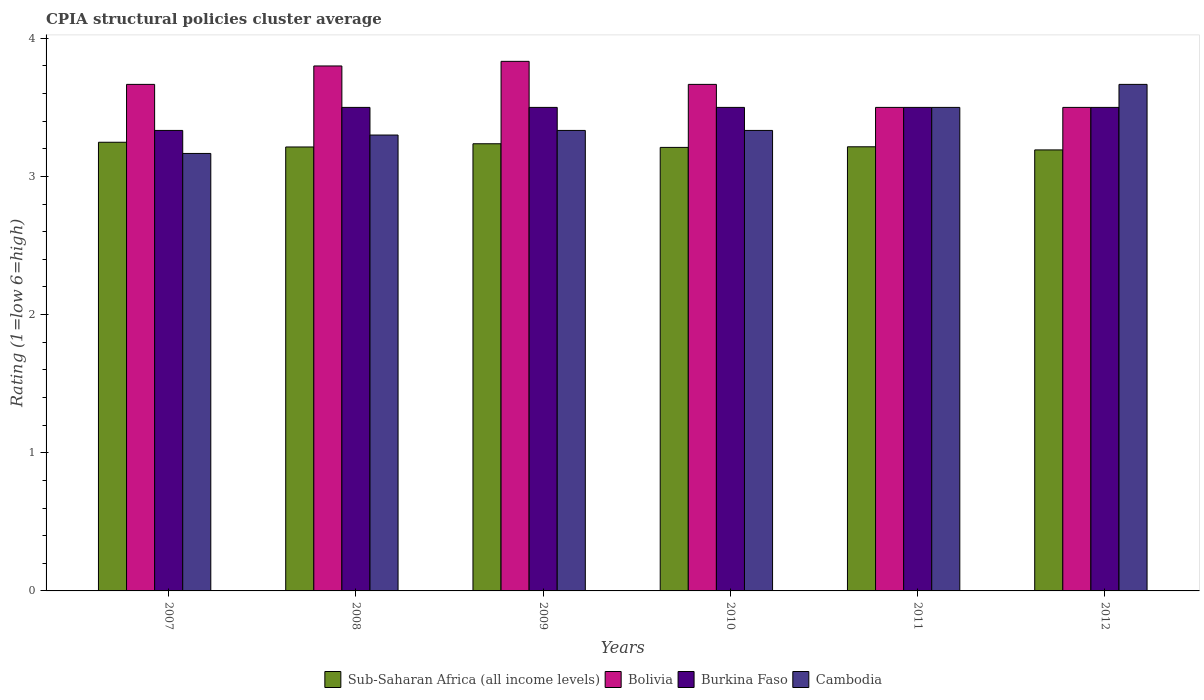How many groups of bars are there?
Provide a short and direct response. 6. Are the number of bars per tick equal to the number of legend labels?
Offer a very short reply. Yes. Are the number of bars on each tick of the X-axis equal?
Provide a succinct answer. Yes. What is the label of the 4th group of bars from the left?
Your response must be concise. 2010. What is the CPIA rating in Cambodia in 2010?
Offer a very short reply. 3.33. Across all years, what is the maximum CPIA rating in Bolivia?
Your answer should be compact. 3.83. Across all years, what is the minimum CPIA rating in Burkina Faso?
Your response must be concise. 3.33. In which year was the CPIA rating in Cambodia maximum?
Make the answer very short. 2012. In which year was the CPIA rating in Cambodia minimum?
Your response must be concise. 2007. What is the total CPIA rating in Bolivia in the graph?
Ensure brevity in your answer.  21.97. What is the difference between the CPIA rating in Sub-Saharan Africa (all income levels) in 2011 and that in 2012?
Provide a short and direct response. 0.02. What is the difference between the CPIA rating in Bolivia in 2010 and the CPIA rating in Sub-Saharan Africa (all income levels) in 2009?
Make the answer very short. 0.43. What is the average CPIA rating in Bolivia per year?
Your response must be concise. 3.66. In the year 2010, what is the difference between the CPIA rating in Bolivia and CPIA rating in Sub-Saharan Africa (all income levels)?
Your response must be concise. 0.46. In how many years, is the CPIA rating in Bolivia greater than 1.4?
Provide a short and direct response. 6. What is the ratio of the CPIA rating in Sub-Saharan Africa (all income levels) in 2011 to that in 2012?
Keep it short and to the point. 1.01. Is the CPIA rating in Sub-Saharan Africa (all income levels) in 2011 less than that in 2012?
Keep it short and to the point. No. Is the difference between the CPIA rating in Bolivia in 2008 and 2009 greater than the difference between the CPIA rating in Sub-Saharan Africa (all income levels) in 2008 and 2009?
Ensure brevity in your answer.  No. What is the difference between the highest and the second highest CPIA rating in Sub-Saharan Africa (all income levels)?
Your answer should be compact. 0.01. What is the difference between the highest and the lowest CPIA rating in Bolivia?
Ensure brevity in your answer.  0.33. In how many years, is the CPIA rating in Sub-Saharan Africa (all income levels) greater than the average CPIA rating in Sub-Saharan Africa (all income levels) taken over all years?
Your response must be concise. 2. How many bars are there?
Offer a very short reply. 24. How many years are there in the graph?
Your answer should be very brief. 6. Are the values on the major ticks of Y-axis written in scientific E-notation?
Make the answer very short. No. Does the graph contain grids?
Provide a succinct answer. No. How many legend labels are there?
Ensure brevity in your answer.  4. What is the title of the graph?
Your answer should be very brief. CPIA structural policies cluster average. What is the label or title of the X-axis?
Make the answer very short. Years. What is the Rating (1=low 6=high) in Sub-Saharan Africa (all income levels) in 2007?
Keep it short and to the point. 3.25. What is the Rating (1=low 6=high) of Bolivia in 2007?
Ensure brevity in your answer.  3.67. What is the Rating (1=low 6=high) of Burkina Faso in 2007?
Provide a succinct answer. 3.33. What is the Rating (1=low 6=high) of Cambodia in 2007?
Provide a succinct answer. 3.17. What is the Rating (1=low 6=high) of Sub-Saharan Africa (all income levels) in 2008?
Offer a terse response. 3.21. What is the Rating (1=low 6=high) of Cambodia in 2008?
Keep it short and to the point. 3.3. What is the Rating (1=low 6=high) of Sub-Saharan Africa (all income levels) in 2009?
Provide a short and direct response. 3.24. What is the Rating (1=low 6=high) in Bolivia in 2009?
Make the answer very short. 3.83. What is the Rating (1=low 6=high) in Burkina Faso in 2009?
Provide a short and direct response. 3.5. What is the Rating (1=low 6=high) of Cambodia in 2009?
Keep it short and to the point. 3.33. What is the Rating (1=low 6=high) in Sub-Saharan Africa (all income levels) in 2010?
Provide a succinct answer. 3.21. What is the Rating (1=low 6=high) of Bolivia in 2010?
Provide a succinct answer. 3.67. What is the Rating (1=low 6=high) in Burkina Faso in 2010?
Offer a very short reply. 3.5. What is the Rating (1=low 6=high) in Cambodia in 2010?
Give a very brief answer. 3.33. What is the Rating (1=low 6=high) of Sub-Saharan Africa (all income levels) in 2011?
Offer a very short reply. 3.21. What is the Rating (1=low 6=high) in Bolivia in 2011?
Provide a succinct answer. 3.5. What is the Rating (1=low 6=high) in Sub-Saharan Africa (all income levels) in 2012?
Offer a terse response. 3.19. What is the Rating (1=low 6=high) of Cambodia in 2012?
Give a very brief answer. 3.67. Across all years, what is the maximum Rating (1=low 6=high) in Sub-Saharan Africa (all income levels)?
Make the answer very short. 3.25. Across all years, what is the maximum Rating (1=low 6=high) in Bolivia?
Provide a succinct answer. 3.83. Across all years, what is the maximum Rating (1=low 6=high) of Cambodia?
Your response must be concise. 3.67. Across all years, what is the minimum Rating (1=low 6=high) of Sub-Saharan Africa (all income levels)?
Offer a very short reply. 3.19. Across all years, what is the minimum Rating (1=low 6=high) of Burkina Faso?
Keep it short and to the point. 3.33. Across all years, what is the minimum Rating (1=low 6=high) in Cambodia?
Give a very brief answer. 3.17. What is the total Rating (1=low 6=high) of Sub-Saharan Africa (all income levels) in the graph?
Provide a short and direct response. 19.32. What is the total Rating (1=low 6=high) in Bolivia in the graph?
Ensure brevity in your answer.  21.97. What is the total Rating (1=low 6=high) in Burkina Faso in the graph?
Ensure brevity in your answer.  20.83. What is the total Rating (1=low 6=high) of Cambodia in the graph?
Keep it short and to the point. 20.3. What is the difference between the Rating (1=low 6=high) of Sub-Saharan Africa (all income levels) in 2007 and that in 2008?
Keep it short and to the point. 0.03. What is the difference between the Rating (1=low 6=high) in Bolivia in 2007 and that in 2008?
Your answer should be very brief. -0.13. What is the difference between the Rating (1=low 6=high) of Burkina Faso in 2007 and that in 2008?
Make the answer very short. -0.17. What is the difference between the Rating (1=low 6=high) of Cambodia in 2007 and that in 2008?
Provide a short and direct response. -0.13. What is the difference between the Rating (1=low 6=high) in Sub-Saharan Africa (all income levels) in 2007 and that in 2009?
Make the answer very short. 0.01. What is the difference between the Rating (1=low 6=high) in Bolivia in 2007 and that in 2009?
Your answer should be compact. -0.17. What is the difference between the Rating (1=low 6=high) of Burkina Faso in 2007 and that in 2009?
Your response must be concise. -0.17. What is the difference between the Rating (1=low 6=high) of Cambodia in 2007 and that in 2009?
Provide a succinct answer. -0.17. What is the difference between the Rating (1=low 6=high) of Sub-Saharan Africa (all income levels) in 2007 and that in 2010?
Keep it short and to the point. 0.04. What is the difference between the Rating (1=low 6=high) of Cambodia in 2007 and that in 2010?
Ensure brevity in your answer.  -0.17. What is the difference between the Rating (1=low 6=high) in Sub-Saharan Africa (all income levels) in 2007 and that in 2011?
Provide a short and direct response. 0.03. What is the difference between the Rating (1=low 6=high) in Bolivia in 2007 and that in 2011?
Offer a terse response. 0.17. What is the difference between the Rating (1=low 6=high) in Sub-Saharan Africa (all income levels) in 2007 and that in 2012?
Offer a very short reply. 0.06. What is the difference between the Rating (1=low 6=high) in Bolivia in 2007 and that in 2012?
Offer a very short reply. 0.17. What is the difference between the Rating (1=low 6=high) in Cambodia in 2007 and that in 2012?
Provide a short and direct response. -0.5. What is the difference between the Rating (1=low 6=high) of Sub-Saharan Africa (all income levels) in 2008 and that in 2009?
Provide a short and direct response. -0.02. What is the difference between the Rating (1=low 6=high) in Bolivia in 2008 and that in 2009?
Provide a short and direct response. -0.03. What is the difference between the Rating (1=low 6=high) in Burkina Faso in 2008 and that in 2009?
Provide a succinct answer. 0. What is the difference between the Rating (1=low 6=high) in Cambodia in 2008 and that in 2009?
Give a very brief answer. -0.03. What is the difference between the Rating (1=low 6=high) of Sub-Saharan Africa (all income levels) in 2008 and that in 2010?
Offer a very short reply. 0. What is the difference between the Rating (1=low 6=high) of Bolivia in 2008 and that in 2010?
Offer a terse response. 0.13. What is the difference between the Rating (1=low 6=high) in Cambodia in 2008 and that in 2010?
Give a very brief answer. -0.03. What is the difference between the Rating (1=low 6=high) in Sub-Saharan Africa (all income levels) in 2008 and that in 2011?
Your answer should be compact. -0. What is the difference between the Rating (1=low 6=high) of Bolivia in 2008 and that in 2011?
Offer a very short reply. 0.3. What is the difference between the Rating (1=low 6=high) of Burkina Faso in 2008 and that in 2011?
Your answer should be compact. 0. What is the difference between the Rating (1=low 6=high) of Cambodia in 2008 and that in 2011?
Offer a terse response. -0.2. What is the difference between the Rating (1=low 6=high) of Sub-Saharan Africa (all income levels) in 2008 and that in 2012?
Offer a very short reply. 0.02. What is the difference between the Rating (1=low 6=high) of Bolivia in 2008 and that in 2012?
Keep it short and to the point. 0.3. What is the difference between the Rating (1=low 6=high) in Cambodia in 2008 and that in 2012?
Your answer should be compact. -0.37. What is the difference between the Rating (1=low 6=high) in Sub-Saharan Africa (all income levels) in 2009 and that in 2010?
Provide a short and direct response. 0.03. What is the difference between the Rating (1=low 6=high) of Bolivia in 2009 and that in 2010?
Make the answer very short. 0.17. What is the difference between the Rating (1=low 6=high) of Burkina Faso in 2009 and that in 2010?
Your response must be concise. 0. What is the difference between the Rating (1=low 6=high) in Cambodia in 2009 and that in 2010?
Your answer should be compact. 0. What is the difference between the Rating (1=low 6=high) of Sub-Saharan Africa (all income levels) in 2009 and that in 2011?
Make the answer very short. 0.02. What is the difference between the Rating (1=low 6=high) of Bolivia in 2009 and that in 2011?
Your answer should be compact. 0.33. What is the difference between the Rating (1=low 6=high) in Sub-Saharan Africa (all income levels) in 2009 and that in 2012?
Keep it short and to the point. 0.04. What is the difference between the Rating (1=low 6=high) of Burkina Faso in 2009 and that in 2012?
Make the answer very short. 0. What is the difference between the Rating (1=low 6=high) in Sub-Saharan Africa (all income levels) in 2010 and that in 2011?
Give a very brief answer. -0. What is the difference between the Rating (1=low 6=high) of Bolivia in 2010 and that in 2011?
Keep it short and to the point. 0.17. What is the difference between the Rating (1=low 6=high) in Cambodia in 2010 and that in 2011?
Provide a succinct answer. -0.17. What is the difference between the Rating (1=low 6=high) of Sub-Saharan Africa (all income levels) in 2010 and that in 2012?
Your response must be concise. 0.02. What is the difference between the Rating (1=low 6=high) in Bolivia in 2010 and that in 2012?
Offer a very short reply. 0.17. What is the difference between the Rating (1=low 6=high) in Burkina Faso in 2010 and that in 2012?
Provide a succinct answer. 0. What is the difference between the Rating (1=low 6=high) in Sub-Saharan Africa (all income levels) in 2011 and that in 2012?
Provide a succinct answer. 0.02. What is the difference between the Rating (1=low 6=high) of Bolivia in 2011 and that in 2012?
Give a very brief answer. 0. What is the difference between the Rating (1=low 6=high) of Sub-Saharan Africa (all income levels) in 2007 and the Rating (1=low 6=high) of Bolivia in 2008?
Offer a terse response. -0.55. What is the difference between the Rating (1=low 6=high) in Sub-Saharan Africa (all income levels) in 2007 and the Rating (1=low 6=high) in Burkina Faso in 2008?
Your answer should be compact. -0.25. What is the difference between the Rating (1=low 6=high) in Sub-Saharan Africa (all income levels) in 2007 and the Rating (1=low 6=high) in Cambodia in 2008?
Offer a very short reply. -0.05. What is the difference between the Rating (1=low 6=high) in Bolivia in 2007 and the Rating (1=low 6=high) in Cambodia in 2008?
Your response must be concise. 0.37. What is the difference between the Rating (1=low 6=high) in Sub-Saharan Africa (all income levels) in 2007 and the Rating (1=low 6=high) in Bolivia in 2009?
Provide a succinct answer. -0.59. What is the difference between the Rating (1=low 6=high) in Sub-Saharan Africa (all income levels) in 2007 and the Rating (1=low 6=high) in Burkina Faso in 2009?
Make the answer very short. -0.25. What is the difference between the Rating (1=low 6=high) in Sub-Saharan Africa (all income levels) in 2007 and the Rating (1=low 6=high) in Cambodia in 2009?
Your answer should be very brief. -0.09. What is the difference between the Rating (1=low 6=high) in Bolivia in 2007 and the Rating (1=low 6=high) in Cambodia in 2009?
Offer a terse response. 0.33. What is the difference between the Rating (1=low 6=high) of Sub-Saharan Africa (all income levels) in 2007 and the Rating (1=low 6=high) of Bolivia in 2010?
Your answer should be compact. -0.42. What is the difference between the Rating (1=low 6=high) in Sub-Saharan Africa (all income levels) in 2007 and the Rating (1=low 6=high) in Burkina Faso in 2010?
Keep it short and to the point. -0.25. What is the difference between the Rating (1=low 6=high) of Sub-Saharan Africa (all income levels) in 2007 and the Rating (1=low 6=high) of Cambodia in 2010?
Your answer should be compact. -0.09. What is the difference between the Rating (1=low 6=high) in Bolivia in 2007 and the Rating (1=low 6=high) in Burkina Faso in 2010?
Make the answer very short. 0.17. What is the difference between the Rating (1=low 6=high) of Bolivia in 2007 and the Rating (1=low 6=high) of Cambodia in 2010?
Your answer should be compact. 0.33. What is the difference between the Rating (1=low 6=high) in Burkina Faso in 2007 and the Rating (1=low 6=high) in Cambodia in 2010?
Give a very brief answer. 0. What is the difference between the Rating (1=low 6=high) in Sub-Saharan Africa (all income levels) in 2007 and the Rating (1=low 6=high) in Bolivia in 2011?
Your response must be concise. -0.25. What is the difference between the Rating (1=low 6=high) in Sub-Saharan Africa (all income levels) in 2007 and the Rating (1=low 6=high) in Burkina Faso in 2011?
Your response must be concise. -0.25. What is the difference between the Rating (1=low 6=high) in Sub-Saharan Africa (all income levels) in 2007 and the Rating (1=low 6=high) in Cambodia in 2011?
Ensure brevity in your answer.  -0.25. What is the difference between the Rating (1=low 6=high) of Bolivia in 2007 and the Rating (1=low 6=high) of Burkina Faso in 2011?
Provide a short and direct response. 0.17. What is the difference between the Rating (1=low 6=high) in Sub-Saharan Africa (all income levels) in 2007 and the Rating (1=low 6=high) in Bolivia in 2012?
Your response must be concise. -0.25. What is the difference between the Rating (1=low 6=high) in Sub-Saharan Africa (all income levels) in 2007 and the Rating (1=low 6=high) in Burkina Faso in 2012?
Your answer should be very brief. -0.25. What is the difference between the Rating (1=low 6=high) of Sub-Saharan Africa (all income levels) in 2007 and the Rating (1=low 6=high) of Cambodia in 2012?
Ensure brevity in your answer.  -0.42. What is the difference between the Rating (1=low 6=high) of Bolivia in 2007 and the Rating (1=low 6=high) of Burkina Faso in 2012?
Your answer should be compact. 0.17. What is the difference between the Rating (1=low 6=high) of Sub-Saharan Africa (all income levels) in 2008 and the Rating (1=low 6=high) of Bolivia in 2009?
Ensure brevity in your answer.  -0.62. What is the difference between the Rating (1=low 6=high) of Sub-Saharan Africa (all income levels) in 2008 and the Rating (1=low 6=high) of Burkina Faso in 2009?
Offer a terse response. -0.29. What is the difference between the Rating (1=low 6=high) in Sub-Saharan Africa (all income levels) in 2008 and the Rating (1=low 6=high) in Cambodia in 2009?
Provide a succinct answer. -0.12. What is the difference between the Rating (1=low 6=high) in Bolivia in 2008 and the Rating (1=low 6=high) in Cambodia in 2009?
Give a very brief answer. 0.47. What is the difference between the Rating (1=low 6=high) in Sub-Saharan Africa (all income levels) in 2008 and the Rating (1=low 6=high) in Bolivia in 2010?
Ensure brevity in your answer.  -0.45. What is the difference between the Rating (1=low 6=high) in Sub-Saharan Africa (all income levels) in 2008 and the Rating (1=low 6=high) in Burkina Faso in 2010?
Keep it short and to the point. -0.29. What is the difference between the Rating (1=low 6=high) of Sub-Saharan Africa (all income levels) in 2008 and the Rating (1=low 6=high) of Cambodia in 2010?
Ensure brevity in your answer.  -0.12. What is the difference between the Rating (1=low 6=high) of Bolivia in 2008 and the Rating (1=low 6=high) of Cambodia in 2010?
Your answer should be compact. 0.47. What is the difference between the Rating (1=low 6=high) in Sub-Saharan Africa (all income levels) in 2008 and the Rating (1=low 6=high) in Bolivia in 2011?
Keep it short and to the point. -0.29. What is the difference between the Rating (1=low 6=high) of Sub-Saharan Africa (all income levels) in 2008 and the Rating (1=low 6=high) of Burkina Faso in 2011?
Your answer should be very brief. -0.29. What is the difference between the Rating (1=low 6=high) of Sub-Saharan Africa (all income levels) in 2008 and the Rating (1=low 6=high) of Cambodia in 2011?
Your response must be concise. -0.29. What is the difference between the Rating (1=low 6=high) of Bolivia in 2008 and the Rating (1=low 6=high) of Cambodia in 2011?
Your answer should be very brief. 0.3. What is the difference between the Rating (1=low 6=high) in Burkina Faso in 2008 and the Rating (1=low 6=high) in Cambodia in 2011?
Make the answer very short. 0. What is the difference between the Rating (1=low 6=high) in Sub-Saharan Africa (all income levels) in 2008 and the Rating (1=low 6=high) in Bolivia in 2012?
Offer a very short reply. -0.29. What is the difference between the Rating (1=low 6=high) of Sub-Saharan Africa (all income levels) in 2008 and the Rating (1=low 6=high) of Burkina Faso in 2012?
Keep it short and to the point. -0.29. What is the difference between the Rating (1=low 6=high) of Sub-Saharan Africa (all income levels) in 2008 and the Rating (1=low 6=high) of Cambodia in 2012?
Your answer should be compact. -0.45. What is the difference between the Rating (1=low 6=high) of Bolivia in 2008 and the Rating (1=low 6=high) of Burkina Faso in 2012?
Offer a very short reply. 0.3. What is the difference between the Rating (1=low 6=high) in Bolivia in 2008 and the Rating (1=low 6=high) in Cambodia in 2012?
Offer a terse response. 0.13. What is the difference between the Rating (1=low 6=high) of Sub-Saharan Africa (all income levels) in 2009 and the Rating (1=low 6=high) of Bolivia in 2010?
Make the answer very short. -0.43. What is the difference between the Rating (1=low 6=high) of Sub-Saharan Africa (all income levels) in 2009 and the Rating (1=low 6=high) of Burkina Faso in 2010?
Provide a succinct answer. -0.26. What is the difference between the Rating (1=low 6=high) of Sub-Saharan Africa (all income levels) in 2009 and the Rating (1=low 6=high) of Cambodia in 2010?
Keep it short and to the point. -0.1. What is the difference between the Rating (1=low 6=high) in Bolivia in 2009 and the Rating (1=low 6=high) in Burkina Faso in 2010?
Your answer should be very brief. 0.33. What is the difference between the Rating (1=low 6=high) of Burkina Faso in 2009 and the Rating (1=low 6=high) of Cambodia in 2010?
Ensure brevity in your answer.  0.17. What is the difference between the Rating (1=low 6=high) in Sub-Saharan Africa (all income levels) in 2009 and the Rating (1=low 6=high) in Bolivia in 2011?
Your answer should be very brief. -0.26. What is the difference between the Rating (1=low 6=high) in Sub-Saharan Africa (all income levels) in 2009 and the Rating (1=low 6=high) in Burkina Faso in 2011?
Keep it short and to the point. -0.26. What is the difference between the Rating (1=low 6=high) of Sub-Saharan Africa (all income levels) in 2009 and the Rating (1=low 6=high) of Cambodia in 2011?
Give a very brief answer. -0.26. What is the difference between the Rating (1=low 6=high) of Bolivia in 2009 and the Rating (1=low 6=high) of Burkina Faso in 2011?
Provide a succinct answer. 0.33. What is the difference between the Rating (1=low 6=high) in Sub-Saharan Africa (all income levels) in 2009 and the Rating (1=low 6=high) in Bolivia in 2012?
Provide a short and direct response. -0.26. What is the difference between the Rating (1=low 6=high) in Sub-Saharan Africa (all income levels) in 2009 and the Rating (1=low 6=high) in Burkina Faso in 2012?
Ensure brevity in your answer.  -0.26. What is the difference between the Rating (1=low 6=high) of Sub-Saharan Africa (all income levels) in 2009 and the Rating (1=low 6=high) of Cambodia in 2012?
Your response must be concise. -0.43. What is the difference between the Rating (1=low 6=high) in Sub-Saharan Africa (all income levels) in 2010 and the Rating (1=low 6=high) in Bolivia in 2011?
Give a very brief answer. -0.29. What is the difference between the Rating (1=low 6=high) of Sub-Saharan Africa (all income levels) in 2010 and the Rating (1=low 6=high) of Burkina Faso in 2011?
Ensure brevity in your answer.  -0.29. What is the difference between the Rating (1=low 6=high) of Sub-Saharan Africa (all income levels) in 2010 and the Rating (1=low 6=high) of Cambodia in 2011?
Offer a very short reply. -0.29. What is the difference between the Rating (1=low 6=high) in Sub-Saharan Africa (all income levels) in 2010 and the Rating (1=low 6=high) in Bolivia in 2012?
Provide a short and direct response. -0.29. What is the difference between the Rating (1=low 6=high) in Sub-Saharan Africa (all income levels) in 2010 and the Rating (1=low 6=high) in Burkina Faso in 2012?
Make the answer very short. -0.29. What is the difference between the Rating (1=low 6=high) in Sub-Saharan Africa (all income levels) in 2010 and the Rating (1=low 6=high) in Cambodia in 2012?
Your answer should be compact. -0.46. What is the difference between the Rating (1=low 6=high) of Bolivia in 2010 and the Rating (1=low 6=high) of Cambodia in 2012?
Keep it short and to the point. 0. What is the difference between the Rating (1=low 6=high) in Burkina Faso in 2010 and the Rating (1=low 6=high) in Cambodia in 2012?
Give a very brief answer. -0.17. What is the difference between the Rating (1=low 6=high) in Sub-Saharan Africa (all income levels) in 2011 and the Rating (1=low 6=high) in Bolivia in 2012?
Provide a short and direct response. -0.29. What is the difference between the Rating (1=low 6=high) in Sub-Saharan Africa (all income levels) in 2011 and the Rating (1=low 6=high) in Burkina Faso in 2012?
Your answer should be compact. -0.29. What is the difference between the Rating (1=low 6=high) of Sub-Saharan Africa (all income levels) in 2011 and the Rating (1=low 6=high) of Cambodia in 2012?
Keep it short and to the point. -0.45. What is the average Rating (1=low 6=high) of Sub-Saharan Africa (all income levels) per year?
Your answer should be compact. 3.22. What is the average Rating (1=low 6=high) of Bolivia per year?
Offer a very short reply. 3.66. What is the average Rating (1=low 6=high) in Burkina Faso per year?
Offer a very short reply. 3.47. What is the average Rating (1=low 6=high) of Cambodia per year?
Ensure brevity in your answer.  3.38. In the year 2007, what is the difference between the Rating (1=low 6=high) of Sub-Saharan Africa (all income levels) and Rating (1=low 6=high) of Bolivia?
Your answer should be very brief. -0.42. In the year 2007, what is the difference between the Rating (1=low 6=high) of Sub-Saharan Africa (all income levels) and Rating (1=low 6=high) of Burkina Faso?
Your answer should be very brief. -0.09. In the year 2007, what is the difference between the Rating (1=low 6=high) of Sub-Saharan Africa (all income levels) and Rating (1=low 6=high) of Cambodia?
Provide a short and direct response. 0.08. In the year 2007, what is the difference between the Rating (1=low 6=high) of Bolivia and Rating (1=low 6=high) of Burkina Faso?
Your answer should be very brief. 0.33. In the year 2007, what is the difference between the Rating (1=low 6=high) in Bolivia and Rating (1=low 6=high) in Cambodia?
Ensure brevity in your answer.  0.5. In the year 2008, what is the difference between the Rating (1=low 6=high) of Sub-Saharan Africa (all income levels) and Rating (1=low 6=high) of Bolivia?
Provide a short and direct response. -0.59. In the year 2008, what is the difference between the Rating (1=low 6=high) in Sub-Saharan Africa (all income levels) and Rating (1=low 6=high) in Burkina Faso?
Keep it short and to the point. -0.29. In the year 2008, what is the difference between the Rating (1=low 6=high) in Sub-Saharan Africa (all income levels) and Rating (1=low 6=high) in Cambodia?
Provide a short and direct response. -0.09. In the year 2008, what is the difference between the Rating (1=low 6=high) in Bolivia and Rating (1=low 6=high) in Cambodia?
Your answer should be compact. 0.5. In the year 2008, what is the difference between the Rating (1=low 6=high) of Burkina Faso and Rating (1=low 6=high) of Cambodia?
Offer a very short reply. 0.2. In the year 2009, what is the difference between the Rating (1=low 6=high) of Sub-Saharan Africa (all income levels) and Rating (1=low 6=high) of Bolivia?
Offer a terse response. -0.6. In the year 2009, what is the difference between the Rating (1=low 6=high) in Sub-Saharan Africa (all income levels) and Rating (1=low 6=high) in Burkina Faso?
Make the answer very short. -0.26. In the year 2009, what is the difference between the Rating (1=low 6=high) in Sub-Saharan Africa (all income levels) and Rating (1=low 6=high) in Cambodia?
Your answer should be very brief. -0.1. In the year 2010, what is the difference between the Rating (1=low 6=high) of Sub-Saharan Africa (all income levels) and Rating (1=low 6=high) of Bolivia?
Make the answer very short. -0.46. In the year 2010, what is the difference between the Rating (1=low 6=high) of Sub-Saharan Africa (all income levels) and Rating (1=low 6=high) of Burkina Faso?
Provide a succinct answer. -0.29. In the year 2010, what is the difference between the Rating (1=low 6=high) of Sub-Saharan Africa (all income levels) and Rating (1=low 6=high) of Cambodia?
Your answer should be compact. -0.12. In the year 2010, what is the difference between the Rating (1=low 6=high) of Bolivia and Rating (1=low 6=high) of Burkina Faso?
Provide a succinct answer. 0.17. In the year 2010, what is the difference between the Rating (1=low 6=high) in Bolivia and Rating (1=low 6=high) in Cambodia?
Your answer should be compact. 0.33. In the year 2011, what is the difference between the Rating (1=low 6=high) in Sub-Saharan Africa (all income levels) and Rating (1=low 6=high) in Bolivia?
Keep it short and to the point. -0.29. In the year 2011, what is the difference between the Rating (1=low 6=high) in Sub-Saharan Africa (all income levels) and Rating (1=low 6=high) in Burkina Faso?
Your response must be concise. -0.29. In the year 2011, what is the difference between the Rating (1=low 6=high) in Sub-Saharan Africa (all income levels) and Rating (1=low 6=high) in Cambodia?
Ensure brevity in your answer.  -0.29. In the year 2011, what is the difference between the Rating (1=low 6=high) of Bolivia and Rating (1=low 6=high) of Burkina Faso?
Offer a terse response. 0. In the year 2012, what is the difference between the Rating (1=low 6=high) of Sub-Saharan Africa (all income levels) and Rating (1=low 6=high) of Bolivia?
Ensure brevity in your answer.  -0.31. In the year 2012, what is the difference between the Rating (1=low 6=high) of Sub-Saharan Africa (all income levels) and Rating (1=low 6=high) of Burkina Faso?
Give a very brief answer. -0.31. In the year 2012, what is the difference between the Rating (1=low 6=high) of Sub-Saharan Africa (all income levels) and Rating (1=low 6=high) of Cambodia?
Offer a terse response. -0.47. In the year 2012, what is the difference between the Rating (1=low 6=high) of Bolivia and Rating (1=low 6=high) of Cambodia?
Your answer should be very brief. -0.17. In the year 2012, what is the difference between the Rating (1=low 6=high) of Burkina Faso and Rating (1=low 6=high) of Cambodia?
Offer a very short reply. -0.17. What is the ratio of the Rating (1=low 6=high) in Sub-Saharan Africa (all income levels) in 2007 to that in 2008?
Your answer should be very brief. 1.01. What is the ratio of the Rating (1=low 6=high) of Bolivia in 2007 to that in 2008?
Your response must be concise. 0.96. What is the ratio of the Rating (1=low 6=high) in Burkina Faso in 2007 to that in 2008?
Provide a short and direct response. 0.95. What is the ratio of the Rating (1=low 6=high) in Cambodia in 2007 to that in 2008?
Make the answer very short. 0.96. What is the ratio of the Rating (1=low 6=high) in Sub-Saharan Africa (all income levels) in 2007 to that in 2009?
Provide a short and direct response. 1. What is the ratio of the Rating (1=low 6=high) in Bolivia in 2007 to that in 2009?
Offer a very short reply. 0.96. What is the ratio of the Rating (1=low 6=high) in Burkina Faso in 2007 to that in 2009?
Offer a very short reply. 0.95. What is the ratio of the Rating (1=low 6=high) in Sub-Saharan Africa (all income levels) in 2007 to that in 2010?
Provide a short and direct response. 1.01. What is the ratio of the Rating (1=low 6=high) of Bolivia in 2007 to that in 2010?
Keep it short and to the point. 1. What is the ratio of the Rating (1=low 6=high) in Sub-Saharan Africa (all income levels) in 2007 to that in 2011?
Keep it short and to the point. 1.01. What is the ratio of the Rating (1=low 6=high) in Bolivia in 2007 to that in 2011?
Offer a terse response. 1.05. What is the ratio of the Rating (1=low 6=high) in Burkina Faso in 2007 to that in 2011?
Your answer should be compact. 0.95. What is the ratio of the Rating (1=low 6=high) of Cambodia in 2007 to that in 2011?
Give a very brief answer. 0.9. What is the ratio of the Rating (1=low 6=high) of Sub-Saharan Africa (all income levels) in 2007 to that in 2012?
Make the answer very short. 1.02. What is the ratio of the Rating (1=low 6=high) in Bolivia in 2007 to that in 2012?
Offer a very short reply. 1.05. What is the ratio of the Rating (1=low 6=high) in Cambodia in 2007 to that in 2012?
Provide a succinct answer. 0.86. What is the ratio of the Rating (1=low 6=high) of Sub-Saharan Africa (all income levels) in 2008 to that in 2009?
Make the answer very short. 0.99. What is the ratio of the Rating (1=low 6=high) in Bolivia in 2008 to that in 2009?
Give a very brief answer. 0.99. What is the ratio of the Rating (1=low 6=high) in Burkina Faso in 2008 to that in 2009?
Offer a very short reply. 1. What is the ratio of the Rating (1=low 6=high) in Sub-Saharan Africa (all income levels) in 2008 to that in 2010?
Give a very brief answer. 1. What is the ratio of the Rating (1=low 6=high) in Bolivia in 2008 to that in 2010?
Ensure brevity in your answer.  1.04. What is the ratio of the Rating (1=low 6=high) of Cambodia in 2008 to that in 2010?
Keep it short and to the point. 0.99. What is the ratio of the Rating (1=low 6=high) in Sub-Saharan Africa (all income levels) in 2008 to that in 2011?
Offer a very short reply. 1. What is the ratio of the Rating (1=low 6=high) of Bolivia in 2008 to that in 2011?
Keep it short and to the point. 1.09. What is the ratio of the Rating (1=low 6=high) in Cambodia in 2008 to that in 2011?
Your response must be concise. 0.94. What is the ratio of the Rating (1=low 6=high) in Sub-Saharan Africa (all income levels) in 2008 to that in 2012?
Make the answer very short. 1.01. What is the ratio of the Rating (1=low 6=high) in Bolivia in 2008 to that in 2012?
Give a very brief answer. 1.09. What is the ratio of the Rating (1=low 6=high) in Burkina Faso in 2008 to that in 2012?
Your response must be concise. 1. What is the ratio of the Rating (1=low 6=high) in Sub-Saharan Africa (all income levels) in 2009 to that in 2010?
Provide a short and direct response. 1.01. What is the ratio of the Rating (1=low 6=high) of Bolivia in 2009 to that in 2010?
Make the answer very short. 1.05. What is the ratio of the Rating (1=low 6=high) in Burkina Faso in 2009 to that in 2010?
Make the answer very short. 1. What is the ratio of the Rating (1=low 6=high) of Sub-Saharan Africa (all income levels) in 2009 to that in 2011?
Make the answer very short. 1.01. What is the ratio of the Rating (1=low 6=high) in Bolivia in 2009 to that in 2011?
Make the answer very short. 1.1. What is the ratio of the Rating (1=low 6=high) of Sub-Saharan Africa (all income levels) in 2009 to that in 2012?
Offer a very short reply. 1.01. What is the ratio of the Rating (1=low 6=high) of Bolivia in 2009 to that in 2012?
Offer a terse response. 1.1. What is the ratio of the Rating (1=low 6=high) of Cambodia in 2009 to that in 2012?
Your answer should be compact. 0.91. What is the ratio of the Rating (1=low 6=high) in Bolivia in 2010 to that in 2011?
Ensure brevity in your answer.  1.05. What is the ratio of the Rating (1=low 6=high) in Burkina Faso in 2010 to that in 2011?
Provide a succinct answer. 1. What is the ratio of the Rating (1=low 6=high) of Cambodia in 2010 to that in 2011?
Make the answer very short. 0.95. What is the ratio of the Rating (1=low 6=high) in Sub-Saharan Africa (all income levels) in 2010 to that in 2012?
Offer a very short reply. 1.01. What is the ratio of the Rating (1=low 6=high) in Bolivia in 2010 to that in 2012?
Your answer should be compact. 1.05. What is the ratio of the Rating (1=low 6=high) of Sub-Saharan Africa (all income levels) in 2011 to that in 2012?
Provide a short and direct response. 1.01. What is the ratio of the Rating (1=low 6=high) in Bolivia in 2011 to that in 2012?
Your answer should be very brief. 1. What is the ratio of the Rating (1=low 6=high) of Cambodia in 2011 to that in 2012?
Offer a very short reply. 0.95. What is the difference between the highest and the second highest Rating (1=low 6=high) in Sub-Saharan Africa (all income levels)?
Keep it short and to the point. 0.01. What is the difference between the highest and the second highest Rating (1=low 6=high) of Burkina Faso?
Your answer should be very brief. 0. What is the difference between the highest and the second highest Rating (1=low 6=high) of Cambodia?
Offer a very short reply. 0.17. What is the difference between the highest and the lowest Rating (1=low 6=high) of Sub-Saharan Africa (all income levels)?
Provide a short and direct response. 0.06. What is the difference between the highest and the lowest Rating (1=low 6=high) of Cambodia?
Offer a very short reply. 0.5. 